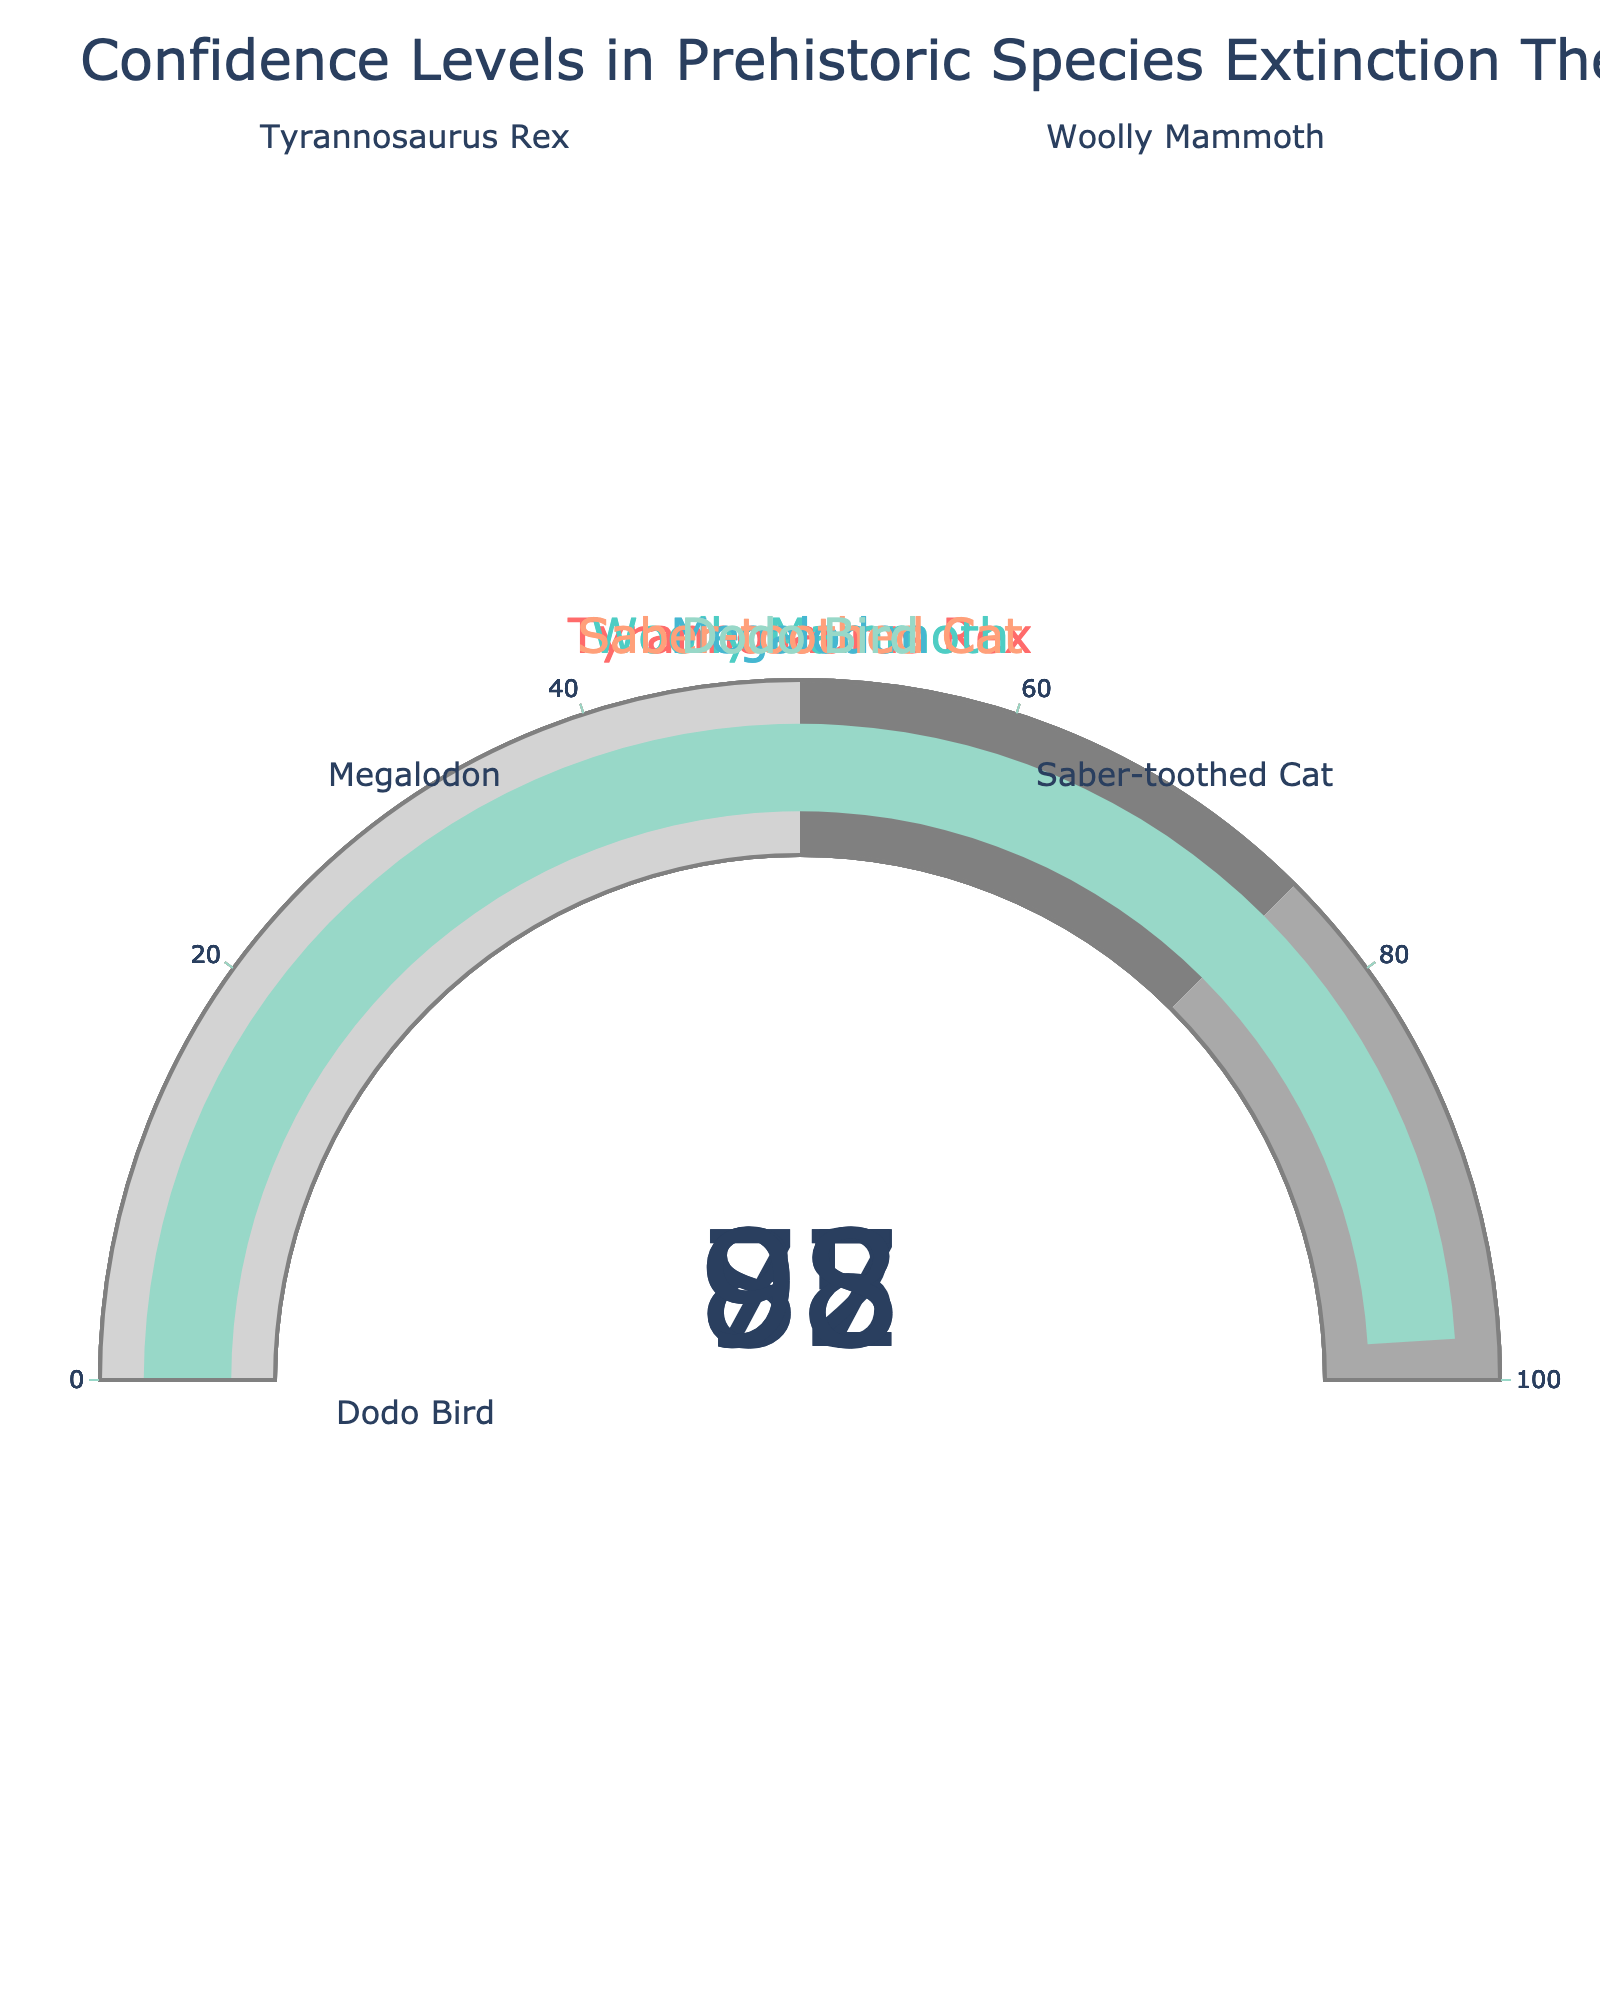Which prehistoric species has the highest confidence level in its extinction theory? By examining all the gauges, we can see the highest confidence value displayed is 98, which belongs to the Dodo Bird.
Answer: Dodo Bird Which prehistoric species has the lowest confidence level in its extinction theory? By viewing the gauges, the lowest confidence value present is 78, which corresponds to the Megalodon.
Answer: Megalodon What is the title of the figure? The title is displayed at the top of the figure and reads "Confidence Levels in Prehistoric Species Extinction Theories".
Answer: Confidence Levels in Prehistoric Species Extinction Theories What are the confidence levels for the Tyrannosaurus Rex and the Saber-toothed Cat combined? The gauge chart shows 87 for the Tyrannosaurus Rex and 85 for the Saber-toothed Cat. Adding these values together, 87 + 85 equals 172.
Answer: 172 Which two species have confidence levels within the range of 80 to 90? Observing the gauges, the Tyrannosaurus Rex has a level of 87 and the Saber-toothed Cat has a level of 85, both of which fall within 80 to 90.
Answer: Tyrannosaurus Rex, Saber-toothed Cat How does the confidence level for the Woolly Mammoth compare with the Megalodon? The Woolly Mammoth has a confidence level of 92 whereas the Megalodon is at 78. So, the Woolly Mammoth's confidence level is higher.
Answer: Woolly Mammoth's is higher What is the average confidence level across all the species? The confidence levels are: 87, 92, 78, 85, and 98. Summing these values gives 440. Dividing by the number of species, 440 / 5 equals 88.
Answer: 88 If you were to adjust the gauge steps, which species' gauge bar would fall into the darkest gray shaded area (75-100) but not overlap, exactly fitting 87 for Tyrannosaurus Rex? Considering the color steps and the value of 87, the Tyrannosaurus Rex’s bar falls within the 75-100 range, which is the darkest gray area.
Answer: Tyrannosaurus Rex What is the difference in confidence levels between the species with the highest and the lowest levels? The species with the highest confidence level is the Dodo Bird at 98, and the one with the lowest is Megalodon at 78. The difference is 98 - 78, which equals 20.
Answer: 20 Which species fall into the top 50% of confidence levels in extinction theories? By ordering the confidence values, we get 78 (Megalodon), 85 (Saber-toothed Cat), 87 (Tyrannosaurus Rex), 92 (Woolly Mammoth), and 98 (Dodo Bird). The top 50% includes the last three entries.
Answer: Tyrannosaurus Rex, Woolly Mammoth, Dodo Bird 